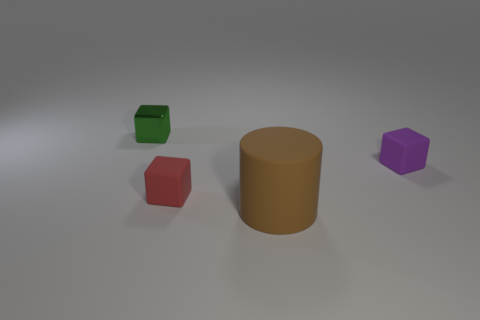There is a tiny object left of the red block; what is it made of?
Ensure brevity in your answer.  Metal. What shape is the rubber object in front of the small rubber cube left of the large brown rubber thing?
Your answer should be very brief. Cylinder. Is the shape of the tiny green shiny thing the same as the matte thing in front of the red rubber object?
Provide a short and direct response. No. There is a tiny rubber cube to the left of the big cylinder; what number of small green objects are to the left of it?
Give a very brief answer. 1. There is a small green object that is the same shape as the small red rubber object; what is its material?
Provide a succinct answer. Metal. What number of blue things are either tiny matte cylinders or metallic cubes?
Your response must be concise. 0. Is there anything else that has the same color as the large thing?
Keep it short and to the point. No. There is a matte object behind the small matte block in front of the small purple object; what is its color?
Your answer should be very brief. Purple. Is the number of large things left of the tiny green metallic block less than the number of tiny green things on the right side of the red cube?
Provide a succinct answer. No. How many objects are small blocks that are behind the purple matte cube or big gray metal cubes?
Give a very brief answer. 1. 